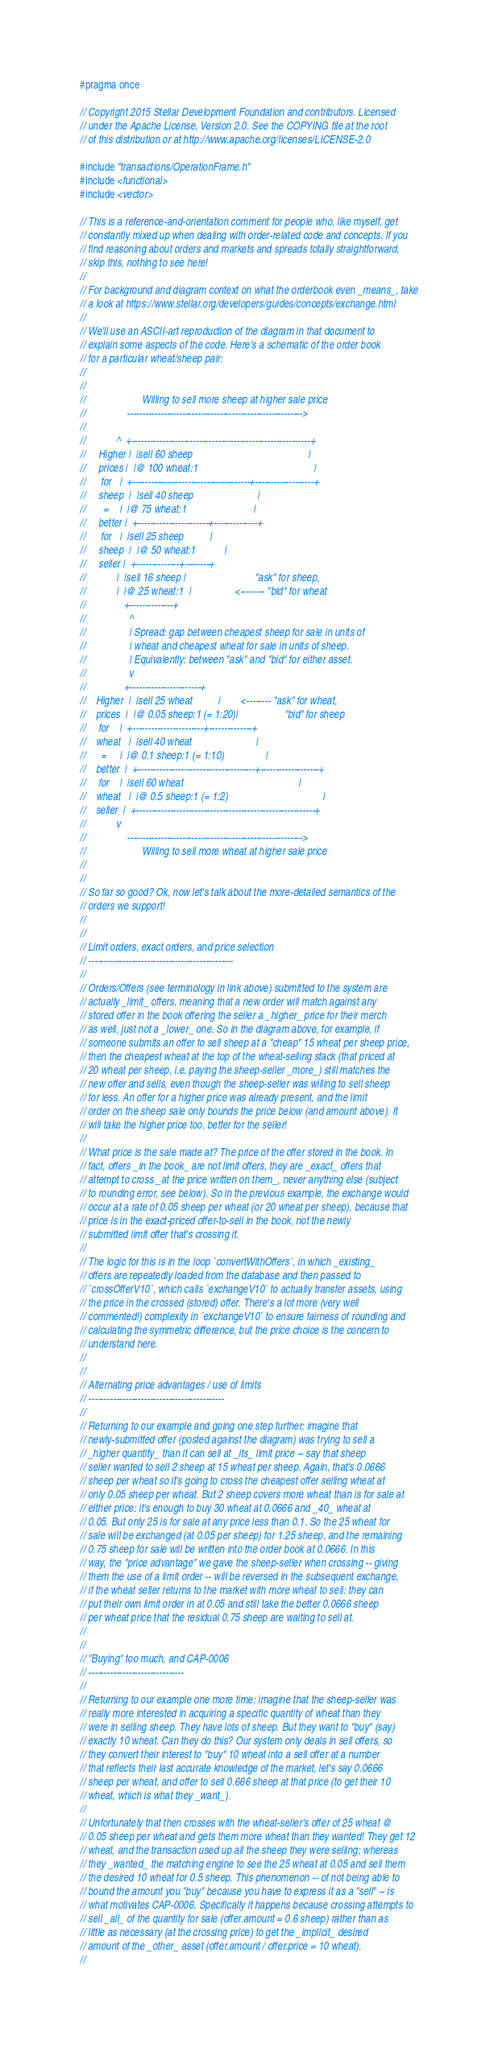<code> <loc_0><loc_0><loc_500><loc_500><_C_>#pragma once

// Copyright 2015 Stellar Development Foundation and contributors. Licensed
// under the Apache License, Version 2.0. See the COPYING file at the root
// of this distribution or at http://www.apache.org/licenses/LICENSE-2.0

#include "transactions/OperationFrame.h"
#include <functional>
#include <vector>

// This is a reference-and-orientation comment for people who, like myself, get
// constantly mixed up when dealing with order-related code and concepts. If you
// find reasoning about orders and markets and spreads totally straightforward,
// skip this, nothing to see here!
//
// For background and diagram context on what the orderbook even _means_, take
// a look at https://www.stellar.org/developers/guides/concepts/exchange.html
//
// We'll use an ASCII-art reproduction of the diagram in that document to
// explain some aspects of the code. Here's a schematic of the order book
// for a particular wheat/sheep pair:
//
//
//                      Willing to sell more sheep at higher sale price
//                --------------------------------------------------------->
//
//            ^  +----------------------------------------------------------+
//     Higher |  |sell 60 sheep                                             |
//     prices |  |@ 100 wheat:1                                             |
//      for   |  +--------------------------------------+-------------------+
//     sheep  |  |sell 40 sheep                         |
//       =    |  |@ 75 wheat:1                          |
//     better |  +-----------------------+--------------+
//      for   |  |sell 25 sheep          |
//     sheep  |  |@ 50 wheat:1           |
//     seller |  +--------------+--------+
//            |  |sell 16 sheep |                           "ask" for sheep,
//            |  |@ 25 wheat:1  |                 <-------- "bid" for wheat
//               +--------------+
//                 ^
//                 | Spread: gap between cheapest sheep for sale in units of
//                 | wheat and cheapest wheat for sale in units of sheep.
//                 | Equivalently: between "ask" and "bid" for either asset.
//                 v
//               +-----------------------+
//    Higher  |  |sell 25 wheat          |        <-------- "ask" for wheat,
//    prices  |  |@ 0.05 sheep:1 (= 1:20)|                  "bid" for sheep
//     for    |  +-----------------------+--------------+
//    wheat   |  |sell 40 wheat                         |
//      =     |  |@ 0.1 sheep:1 (= 1:10)                |
//    better  |  +--------------------------------------+-------------------+
//     for    |  |sell 60 wheat                                             |
//    wheat   |  |@ 0.5 sheep:1 (= 1:2)                                     |
//    seller  |  +----------------------------------------------------------+
//            v
//                --------------------------------------------------------->
//                      Willing to sell more wheat at higher sale price
//
//
// So far so good? Ok, now let's talk about the more-detailed semantics of the
// orders we support!
//
//
// Limit orders, exact orders, and price selection
// -----------------------------------------------
//
// Orders/Offers (see terminology in link above) submitted to the system are
// actually _limit_ offers, meaning that a new order will match against any
// stored offer in the book offering the seller a _higher_ price for their merch
// as well, just not a _lower_ one. So in the diagram above, for example, if
// someone submits an offer to sell sheep at a "cheap" 15 wheat per sheep price,
// then the cheapest wheat at the top of the wheat-selling stack (that priced at
// 20 wheat per sheep, i.e. paying the sheep-seller _more_) still matches the
// new offer and sells, even though the sheep-seller was willing to sell sheep
// for less. An offer for a higher price was already present, and the limit
// order on the sheep sale only bounds the price below (and amount above). It
// will take the higher price too, better for the seller!
//
// What price is the sale made at? The price of the offer stored in the book. In
// fact, offers _in the book_ are not limit offers, they are _exact_ offers that
// attempt to cross _at the price written on them_, never anything else (subject
// to rounding error, see below). So in the previous example, the exchange would
// occur at a rate of 0.05 sheep per wheat (or 20 wheat per sheep), because that
// price is in the exact-priced offer-to-sell in the book, not the newly
// submitted limit offer that's crossing it.
//
// The logic for this is in the loop `convertWithOffers`, in which _existing_
// offers are repeatedly loaded from the database and then passed to
// `crossOfferV10`, which calls `exchangeV10` to actually transfer assets, using
// the price in the crossed (stored) offer. There's a lot more (very well
// commented!) complexity in `exchangeV10` to ensure fairness of rounding and
// calculating the symmetric difference, but the price choice is the concern to
// understand here.
//
//
// Alternating price advantages / use of limits
// --------------------------------------------
//
// Returning to our example and going one step further: imagine that
// newly-submitted offer (posted against the diagram) was trying to sell a
// _higher quantity_ than it can sell at _its_ limit price -- say that sheep
// seller wanted to sell 2 sheep at 15 wheat per sheep. Again, that's 0.0666
// sheep per wheat so it's going to cross the cheapest offer selling wheat at
// only 0.05 sheep per wheat. But 2 sheep covers more wheat than is for sale at
// either price: it's enough to buy 30 wheat at 0.0666 and _40_ wheat at
// 0.05. But only 25 is for sale at any price less than 0.1. So the 25 wheat for
// sale will be exchanged (at 0.05 per sheep) for 1.25 sheep, and the remaining
// 0.75 sheep for sale will be written into the order book at 0.0666. In this
// way, the "price advantage" we gave the sheep-seller when crossing -- giving
// them the use of a limit order -- will be reversed in the subsequent exchange,
// if the wheat seller returns to the market with more wheat to sell: they can
// put their own limit order in at 0.05 and still take the better 0.0666 sheep
// per wheat price that the residual 0.75 sheep are waiting to sell at.
//
//
// "Buying" too much, and CAP-0006
// -------------------------------
//
// Returning to our example one more time: imagine that the sheep-seller was
// really more interested in acquiring a specific quantity of wheat than they
// were in selling sheep. They have lots of sheep. But they want to "buy" (say)
// exactly 10 wheat. Can they do this? Our system only deals in sell offers, so
// they convert their interest to "buy" 10 wheat into a sell offer at a number
// that reflects their last accurate knowledge of the market, let's say 0.0666
// sheep per wheat, and offer to sell 0.666 sheep at that price (to get their 10
// wheat, which is what they _want_).
//
// Unfortunately that then crosses with the wheat-seller's offer of 25 wheat @
// 0.05 sheep per wheat and gets them more wheat than they wanted! They get 12
// wheat, and the transaction used up all the sheep they were selling; whereas
// they _wanted_ the matching engine to see the 25 wheat at 0.05 and sell them
// the desired 10 wheat for 0.5 sheep. This phenomenon -- of not being able to
// bound the amount you "buy" because you have to express it as a "sell" -- is
// what motivates CAP-0006. Specifically it happens because crossing attempts to
// sell _all_ of the quantity for sale (offer.amount = 0.6 sheep) rather than as
// little as necessary (at the crossing price) to get the _implicit_ desired
// amount of the _other_ asset (offer.amount / offer.price = 10 wheat).
//</code> 